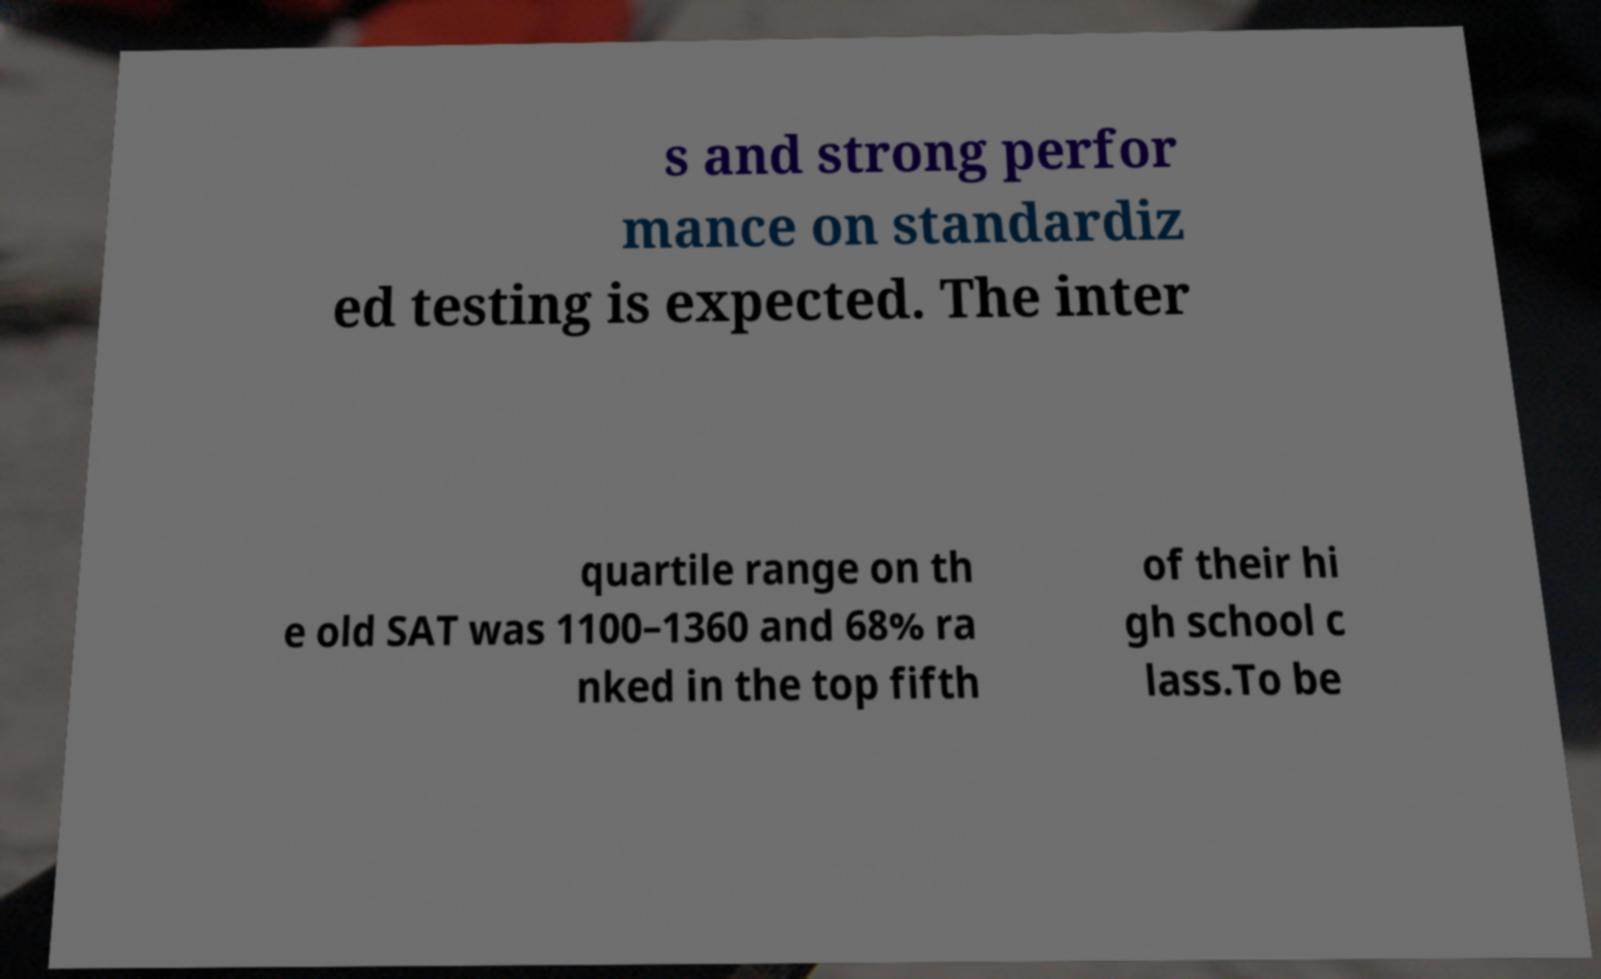Can you accurately transcribe the text from the provided image for me? s and strong perfor mance on standardiz ed testing is expected. The inter quartile range on th e old SAT was 1100–1360 and 68% ra nked in the top fifth of their hi gh school c lass.To be 